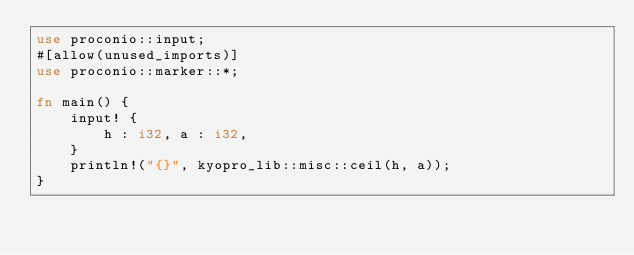<code> <loc_0><loc_0><loc_500><loc_500><_Rust_>use proconio::input;
#[allow(unused_imports)]
use proconio::marker::*;

fn main() {
    input! {
        h : i32, a : i32,
    }
    println!("{}", kyopro_lib::misc::ceil(h, a));
}
</code> 